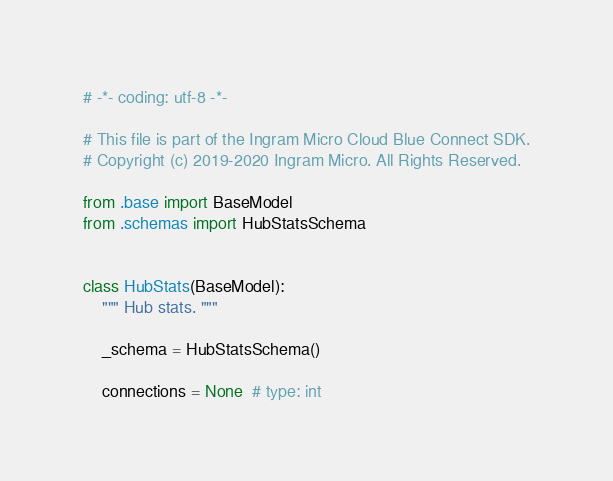Convert code to text. <code><loc_0><loc_0><loc_500><loc_500><_Python_># -*- coding: utf-8 -*-

# This file is part of the Ingram Micro Cloud Blue Connect SDK.
# Copyright (c) 2019-2020 Ingram Micro. All Rights Reserved.

from .base import BaseModel
from .schemas import HubStatsSchema


class HubStats(BaseModel):
    """ Hub stats. """

    _schema = HubStatsSchema()

    connections = None  # type: int</code> 